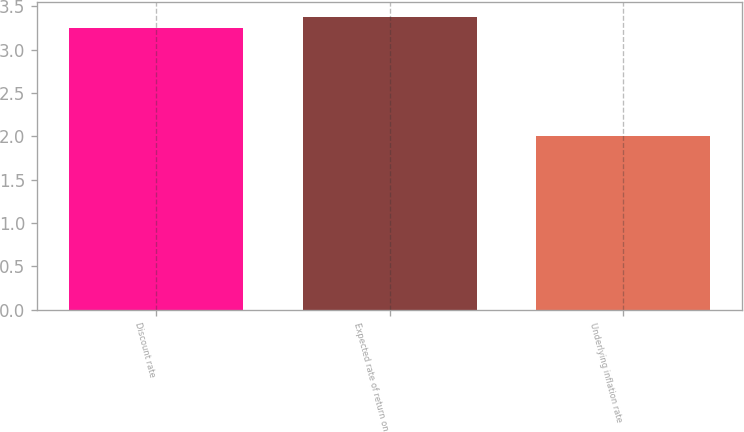Convert chart. <chart><loc_0><loc_0><loc_500><loc_500><bar_chart><fcel>Discount rate<fcel>Expected rate of return on<fcel>Underlying inflation rate<nl><fcel>3.25<fcel>3.38<fcel>2<nl></chart> 